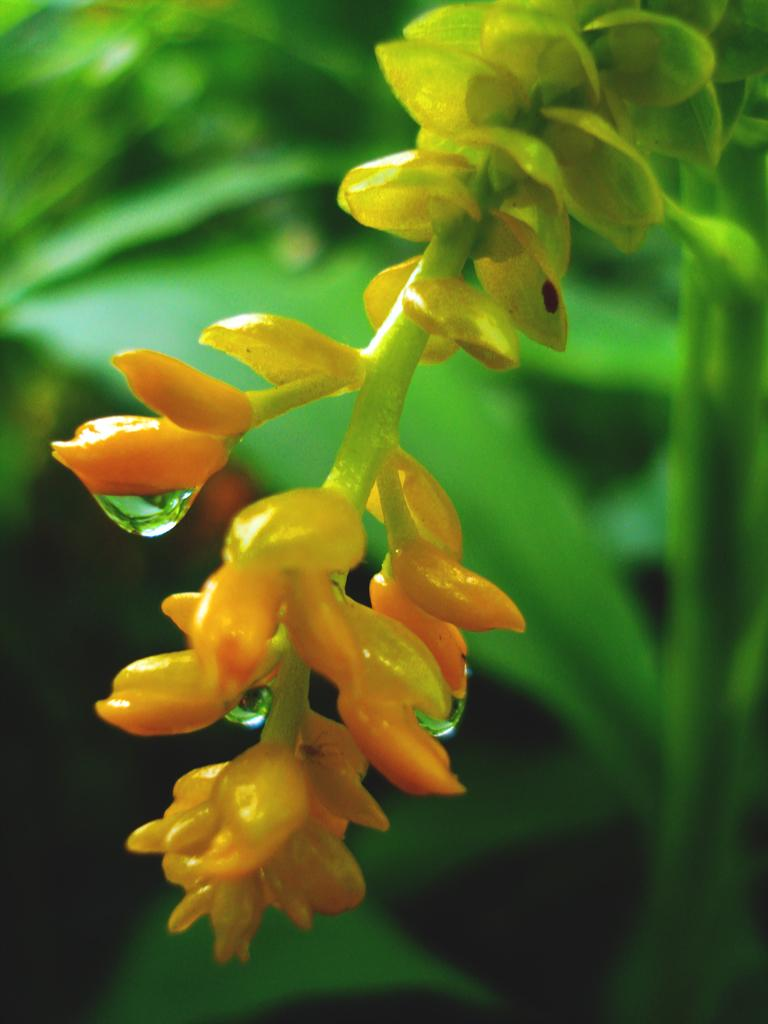What is the main subject of the image? The main subject of the image is a flower, as it is a macro photography of a flower. Are there any other parts of the plant visible in the image? Yes, there are leaves of the plant visible in the image. How is the background of the image depicted? The background of the image is blurred. How many frogs can be seen sitting on the leaves in the image? There are no frogs present in the image; it is a macro photography of a flower with leaves. What is the aftermath of the storm in the image? There is no mention of a storm or any aftermath in the image; it is a close-up of a flower and its leaves. 